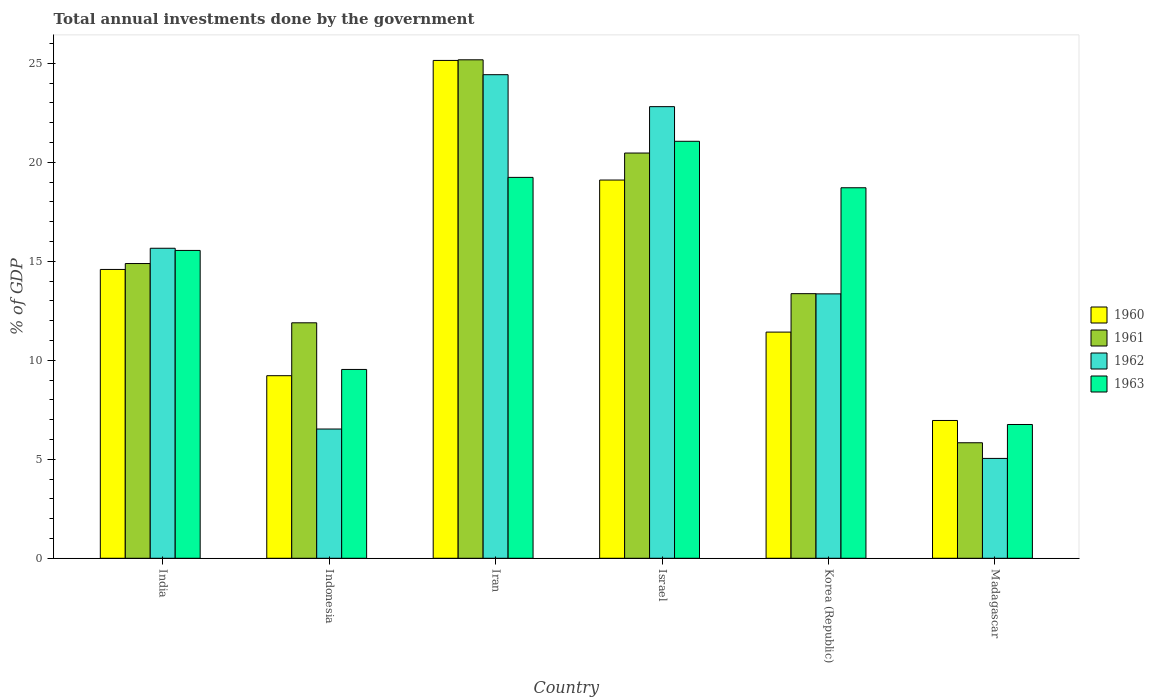How many different coloured bars are there?
Your response must be concise. 4. How many groups of bars are there?
Your answer should be very brief. 6. Are the number of bars per tick equal to the number of legend labels?
Offer a very short reply. Yes. Are the number of bars on each tick of the X-axis equal?
Offer a very short reply. Yes. How many bars are there on the 3rd tick from the left?
Your answer should be compact. 4. What is the label of the 3rd group of bars from the left?
Make the answer very short. Iran. In how many cases, is the number of bars for a given country not equal to the number of legend labels?
Offer a very short reply. 0. What is the total annual investments done by the government in 1962 in Madagascar?
Your response must be concise. 5.04. Across all countries, what is the maximum total annual investments done by the government in 1962?
Offer a terse response. 24.43. Across all countries, what is the minimum total annual investments done by the government in 1963?
Make the answer very short. 6.76. In which country was the total annual investments done by the government in 1962 maximum?
Provide a short and direct response. Iran. In which country was the total annual investments done by the government in 1961 minimum?
Ensure brevity in your answer.  Madagascar. What is the total total annual investments done by the government in 1960 in the graph?
Your answer should be very brief. 86.46. What is the difference between the total annual investments done by the government in 1963 in India and that in Israel?
Give a very brief answer. -5.51. What is the difference between the total annual investments done by the government in 1962 in India and the total annual investments done by the government in 1963 in Israel?
Your response must be concise. -5.4. What is the average total annual investments done by the government in 1962 per country?
Give a very brief answer. 14.64. What is the difference between the total annual investments done by the government of/in 1962 and total annual investments done by the government of/in 1961 in Korea (Republic)?
Your response must be concise. -0.01. What is the ratio of the total annual investments done by the government in 1962 in Iran to that in Madagascar?
Your response must be concise. 4.84. Is the total annual investments done by the government in 1960 in Israel less than that in Madagascar?
Offer a terse response. No. Is the difference between the total annual investments done by the government in 1962 in Indonesia and Iran greater than the difference between the total annual investments done by the government in 1961 in Indonesia and Iran?
Offer a terse response. No. What is the difference between the highest and the second highest total annual investments done by the government in 1962?
Your answer should be compact. 1.61. What is the difference between the highest and the lowest total annual investments done by the government in 1961?
Provide a succinct answer. 19.35. What does the 1st bar from the left in Israel represents?
Your answer should be compact. 1960. How many bars are there?
Offer a terse response. 24. How many countries are there in the graph?
Give a very brief answer. 6. Are the values on the major ticks of Y-axis written in scientific E-notation?
Provide a succinct answer. No. Does the graph contain grids?
Keep it short and to the point. No. How many legend labels are there?
Provide a short and direct response. 4. What is the title of the graph?
Your answer should be very brief. Total annual investments done by the government. Does "1981" appear as one of the legend labels in the graph?
Offer a very short reply. No. What is the label or title of the Y-axis?
Provide a succinct answer. % of GDP. What is the % of GDP in 1960 in India?
Your answer should be very brief. 14.59. What is the % of GDP in 1961 in India?
Provide a succinct answer. 14.89. What is the % of GDP in 1962 in India?
Keep it short and to the point. 15.66. What is the % of GDP in 1963 in India?
Your answer should be compact. 15.55. What is the % of GDP of 1960 in Indonesia?
Your answer should be compact. 9.22. What is the % of GDP in 1961 in Indonesia?
Keep it short and to the point. 11.9. What is the % of GDP in 1962 in Indonesia?
Offer a very short reply. 6.53. What is the % of GDP in 1963 in Indonesia?
Your answer should be compact. 9.54. What is the % of GDP of 1960 in Iran?
Ensure brevity in your answer.  25.15. What is the % of GDP in 1961 in Iran?
Your answer should be very brief. 25.18. What is the % of GDP in 1962 in Iran?
Your response must be concise. 24.43. What is the % of GDP of 1963 in Iran?
Offer a very short reply. 19.24. What is the % of GDP of 1960 in Israel?
Make the answer very short. 19.11. What is the % of GDP of 1961 in Israel?
Give a very brief answer. 20.47. What is the % of GDP of 1962 in Israel?
Provide a succinct answer. 22.82. What is the % of GDP of 1963 in Israel?
Ensure brevity in your answer.  21.06. What is the % of GDP of 1960 in Korea (Republic)?
Make the answer very short. 11.43. What is the % of GDP of 1961 in Korea (Republic)?
Ensure brevity in your answer.  13.37. What is the % of GDP of 1962 in Korea (Republic)?
Make the answer very short. 13.36. What is the % of GDP in 1963 in Korea (Republic)?
Keep it short and to the point. 18.72. What is the % of GDP of 1960 in Madagascar?
Keep it short and to the point. 6.96. What is the % of GDP of 1961 in Madagascar?
Your response must be concise. 5.84. What is the % of GDP of 1962 in Madagascar?
Offer a very short reply. 5.04. What is the % of GDP of 1963 in Madagascar?
Your answer should be very brief. 6.76. Across all countries, what is the maximum % of GDP of 1960?
Offer a very short reply. 25.15. Across all countries, what is the maximum % of GDP of 1961?
Offer a very short reply. 25.18. Across all countries, what is the maximum % of GDP in 1962?
Provide a short and direct response. 24.43. Across all countries, what is the maximum % of GDP of 1963?
Your answer should be very brief. 21.06. Across all countries, what is the minimum % of GDP of 1960?
Provide a short and direct response. 6.96. Across all countries, what is the minimum % of GDP in 1961?
Give a very brief answer. 5.84. Across all countries, what is the minimum % of GDP in 1962?
Provide a succinct answer. 5.04. Across all countries, what is the minimum % of GDP of 1963?
Give a very brief answer. 6.76. What is the total % of GDP of 1960 in the graph?
Your response must be concise. 86.46. What is the total % of GDP of 1961 in the graph?
Offer a terse response. 91.64. What is the total % of GDP in 1962 in the graph?
Give a very brief answer. 87.84. What is the total % of GDP of 1963 in the graph?
Provide a succinct answer. 90.87. What is the difference between the % of GDP of 1960 in India and that in Indonesia?
Provide a short and direct response. 5.37. What is the difference between the % of GDP of 1961 in India and that in Indonesia?
Provide a succinct answer. 2.99. What is the difference between the % of GDP of 1962 in India and that in Indonesia?
Provide a succinct answer. 9.13. What is the difference between the % of GDP in 1963 in India and that in Indonesia?
Your response must be concise. 6.01. What is the difference between the % of GDP of 1960 in India and that in Iran?
Your answer should be very brief. -10.56. What is the difference between the % of GDP in 1961 in India and that in Iran?
Your answer should be very brief. -10.29. What is the difference between the % of GDP in 1962 in India and that in Iran?
Your response must be concise. -8.77. What is the difference between the % of GDP of 1963 in India and that in Iran?
Give a very brief answer. -3.69. What is the difference between the % of GDP of 1960 in India and that in Israel?
Give a very brief answer. -4.52. What is the difference between the % of GDP of 1961 in India and that in Israel?
Keep it short and to the point. -5.58. What is the difference between the % of GDP in 1962 in India and that in Israel?
Keep it short and to the point. -7.15. What is the difference between the % of GDP of 1963 in India and that in Israel?
Offer a terse response. -5.51. What is the difference between the % of GDP in 1960 in India and that in Korea (Republic)?
Keep it short and to the point. 3.17. What is the difference between the % of GDP of 1961 in India and that in Korea (Republic)?
Provide a short and direct response. 1.52. What is the difference between the % of GDP in 1962 in India and that in Korea (Republic)?
Ensure brevity in your answer.  2.3. What is the difference between the % of GDP of 1963 in India and that in Korea (Republic)?
Ensure brevity in your answer.  -3.17. What is the difference between the % of GDP in 1960 in India and that in Madagascar?
Make the answer very short. 7.63. What is the difference between the % of GDP of 1961 in India and that in Madagascar?
Your response must be concise. 9.05. What is the difference between the % of GDP of 1962 in India and that in Madagascar?
Offer a terse response. 10.62. What is the difference between the % of GDP of 1963 in India and that in Madagascar?
Your answer should be compact. 8.79. What is the difference between the % of GDP of 1960 in Indonesia and that in Iran?
Offer a very short reply. -15.93. What is the difference between the % of GDP in 1961 in Indonesia and that in Iran?
Your answer should be very brief. -13.29. What is the difference between the % of GDP of 1962 in Indonesia and that in Iran?
Provide a short and direct response. -17.9. What is the difference between the % of GDP of 1963 in Indonesia and that in Iran?
Keep it short and to the point. -9.7. What is the difference between the % of GDP in 1960 in Indonesia and that in Israel?
Make the answer very short. -9.88. What is the difference between the % of GDP in 1961 in Indonesia and that in Israel?
Your response must be concise. -8.58. What is the difference between the % of GDP in 1962 in Indonesia and that in Israel?
Your answer should be compact. -16.29. What is the difference between the % of GDP in 1963 in Indonesia and that in Israel?
Your answer should be very brief. -11.53. What is the difference between the % of GDP in 1960 in Indonesia and that in Korea (Republic)?
Offer a terse response. -2.2. What is the difference between the % of GDP of 1961 in Indonesia and that in Korea (Republic)?
Provide a short and direct response. -1.47. What is the difference between the % of GDP in 1962 in Indonesia and that in Korea (Republic)?
Offer a terse response. -6.83. What is the difference between the % of GDP in 1963 in Indonesia and that in Korea (Republic)?
Make the answer very short. -9.18. What is the difference between the % of GDP in 1960 in Indonesia and that in Madagascar?
Offer a terse response. 2.26. What is the difference between the % of GDP of 1961 in Indonesia and that in Madagascar?
Your answer should be compact. 6.06. What is the difference between the % of GDP of 1962 in Indonesia and that in Madagascar?
Your answer should be very brief. 1.49. What is the difference between the % of GDP in 1963 in Indonesia and that in Madagascar?
Ensure brevity in your answer.  2.78. What is the difference between the % of GDP of 1960 in Iran and that in Israel?
Offer a terse response. 6.04. What is the difference between the % of GDP of 1961 in Iran and that in Israel?
Ensure brevity in your answer.  4.71. What is the difference between the % of GDP of 1962 in Iran and that in Israel?
Provide a succinct answer. 1.61. What is the difference between the % of GDP in 1963 in Iran and that in Israel?
Offer a very short reply. -1.82. What is the difference between the % of GDP in 1960 in Iran and that in Korea (Republic)?
Your answer should be very brief. 13.72. What is the difference between the % of GDP in 1961 in Iran and that in Korea (Republic)?
Give a very brief answer. 11.81. What is the difference between the % of GDP in 1962 in Iran and that in Korea (Republic)?
Make the answer very short. 11.07. What is the difference between the % of GDP in 1963 in Iran and that in Korea (Republic)?
Offer a very short reply. 0.52. What is the difference between the % of GDP of 1960 in Iran and that in Madagascar?
Give a very brief answer. 18.19. What is the difference between the % of GDP of 1961 in Iran and that in Madagascar?
Offer a very short reply. 19.35. What is the difference between the % of GDP in 1962 in Iran and that in Madagascar?
Ensure brevity in your answer.  19.38. What is the difference between the % of GDP in 1963 in Iran and that in Madagascar?
Offer a very short reply. 12.48. What is the difference between the % of GDP in 1960 in Israel and that in Korea (Republic)?
Keep it short and to the point. 7.68. What is the difference between the % of GDP of 1961 in Israel and that in Korea (Republic)?
Your response must be concise. 7.1. What is the difference between the % of GDP of 1962 in Israel and that in Korea (Republic)?
Give a very brief answer. 9.46. What is the difference between the % of GDP of 1963 in Israel and that in Korea (Republic)?
Ensure brevity in your answer.  2.35. What is the difference between the % of GDP in 1960 in Israel and that in Madagascar?
Make the answer very short. 12.15. What is the difference between the % of GDP in 1961 in Israel and that in Madagascar?
Give a very brief answer. 14.64. What is the difference between the % of GDP in 1962 in Israel and that in Madagascar?
Your answer should be very brief. 17.77. What is the difference between the % of GDP of 1963 in Israel and that in Madagascar?
Make the answer very short. 14.31. What is the difference between the % of GDP of 1960 in Korea (Republic) and that in Madagascar?
Keep it short and to the point. 4.46. What is the difference between the % of GDP of 1961 in Korea (Republic) and that in Madagascar?
Keep it short and to the point. 7.53. What is the difference between the % of GDP of 1962 in Korea (Republic) and that in Madagascar?
Your answer should be very brief. 8.31. What is the difference between the % of GDP in 1963 in Korea (Republic) and that in Madagascar?
Make the answer very short. 11.96. What is the difference between the % of GDP in 1960 in India and the % of GDP in 1961 in Indonesia?
Provide a short and direct response. 2.7. What is the difference between the % of GDP in 1960 in India and the % of GDP in 1962 in Indonesia?
Provide a succinct answer. 8.06. What is the difference between the % of GDP of 1960 in India and the % of GDP of 1963 in Indonesia?
Make the answer very short. 5.05. What is the difference between the % of GDP in 1961 in India and the % of GDP in 1962 in Indonesia?
Provide a short and direct response. 8.36. What is the difference between the % of GDP in 1961 in India and the % of GDP in 1963 in Indonesia?
Offer a very short reply. 5.35. What is the difference between the % of GDP in 1962 in India and the % of GDP in 1963 in Indonesia?
Offer a very short reply. 6.12. What is the difference between the % of GDP in 1960 in India and the % of GDP in 1961 in Iran?
Keep it short and to the point. -10.59. What is the difference between the % of GDP of 1960 in India and the % of GDP of 1962 in Iran?
Offer a very short reply. -9.84. What is the difference between the % of GDP in 1960 in India and the % of GDP in 1963 in Iran?
Give a very brief answer. -4.65. What is the difference between the % of GDP in 1961 in India and the % of GDP in 1962 in Iran?
Your response must be concise. -9.54. What is the difference between the % of GDP of 1961 in India and the % of GDP of 1963 in Iran?
Your response must be concise. -4.35. What is the difference between the % of GDP of 1962 in India and the % of GDP of 1963 in Iran?
Offer a very short reply. -3.58. What is the difference between the % of GDP in 1960 in India and the % of GDP in 1961 in Israel?
Ensure brevity in your answer.  -5.88. What is the difference between the % of GDP in 1960 in India and the % of GDP in 1962 in Israel?
Your answer should be very brief. -8.22. What is the difference between the % of GDP in 1960 in India and the % of GDP in 1963 in Israel?
Ensure brevity in your answer.  -6.47. What is the difference between the % of GDP in 1961 in India and the % of GDP in 1962 in Israel?
Your answer should be very brief. -7.93. What is the difference between the % of GDP of 1961 in India and the % of GDP of 1963 in Israel?
Provide a short and direct response. -6.18. What is the difference between the % of GDP in 1962 in India and the % of GDP in 1963 in Israel?
Give a very brief answer. -5.4. What is the difference between the % of GDP of 1960 in India and the % of GDP of 1961 in Korea (Republic)?
Your answer should be very brief. 1.22. What is the difference between the % of GDP in 1960 in India and the % of GDP in 1962 in Korea (Republic)?
Your answer should be compact. 1.23. What is the difference between the % of GDP in 1960 in India and the % of GDP in 1963 in Korea (Republic)?
Your response must be concise. -4.13. What is the difference between the % of GDP in 1961 in India and the % of GDP in 1962 in Korea (Republic)?
Your answer should be very brief. 1.53. What is the difference between the % of GDP in 1961 in India and the % of GDP in 1963 in Korea (Republic)?
Your answer should be very brief. -3.83. What is the difference between the % of GDP in 1962 in India and the % of GDP in 1963 in Korea (Republic)?
Provide a short and direct response. -3.06. What is the difference between the % of GDP in 1960 in India and the % of GDP in 1961 in Madagascar?
Provide a succinct answer. 8.76. What is the difference between the % of GDP of 1960 in India and the % of GDP of 1962 in Madagascar?
Provide a succinct answer. 9.55. What is the difference between the % of GDP in 1960 in India and the % of GDP in 1963 in Madagascar?
Your answer should be compact. 7.83. What is the difference between the % of GDP of 1961 in India and the % of GDP of 1962 in Madagascar?
Provide a succinct answer. 9.84. What is the difference between the % of GDP in 1961 in India and the % of GDP in 1963 in Madagascar?
Your response must be concise. 8.13. What is the difference between the % of GDP of 1962 in India and the % of GDP of 1963 in Madagascar?
Your answer should be compact. 8.9. What is the difference between the % of GDP in 1960 in Indonesia and the % of GDP in 1961 in Iran?
Offer a very short reply. -15.96. What is the difference between the % of GDP of 1960 in Indonesia and the % of GDP of 1962 in Iran?
Offer a very short reply. -15.21. What is the difference between the % of GDP in 1960 in Indonesia and the % of GDP in 1963 in Iran?
Your response must be concise. -10.02. What is the difference between the % of GDP in 1961 in Indonesia and the % of GDP in 1962 in Iran?
Your answer should be compact. -12.53. What is the difference between the % of GDP in 1961 in Indonesia and the % of GDP in 1963 in Iran?
Make the answer very short. -7.35. What is the difference between the % of GDP in 1962 in Indonesia and the % of GDP in 1963 in Iran?
Make the answer very short. -12.71. What is the difference between the % of GDP of 1960 in Indonesia and the % of GDP of 1961 in Israel?
Give a very brief answer. -11.25. What is the difference between the % of GDP in 1960 in Indonesia and the % of GDP in 1962 in Israel?
Your response must be concise. -13.59. What is the difference between the % of GDP of 1960 in Indonesia and the % of GDP of 1963 in Israel?
Provide a succinct answer. -11.84. What is the difference between the % of GDP of 1961 in Indonesia and the % of GDP of 1962 in Israel?
Your answer should be very brief. -10.92. What is the difference between the % of GDP in 1961 in Indonesia and the % of GDP in 1963 in Israel?
Provide a short and direct response. -9.17. What is the difference between the % of GDP of 1962 in Indonesia and the % of GDP of 1963 in Israel?
Provide a succinct answer. -14.54. What is the difference between the % of GDP in 1960 in Indonesia and the % of GDP in 1961 in Korea (Republic)?
Offer a very short reply. -4.14. What is the difference between the % of GDP of 1960 in Indonesia and the % of GDP of 1962 in Korea (Republic)?
Your answer should be very brief. -4.13. What is the difference between the % of GDP in 1960 in Indonesia and the % of GDP in 1963 in Korea (Republic)?
Your response must be concise. -9.49. What is the difference between the % of GDP in 1961 in Indonesia and the % of GDP in 1962 in Korea (Republic)?
Offer a terse response. -1.46. What is the difference between the % of GDP of 1961 in Indonesia and the % of GDP of 1963 in Korea (Republic)?
Ensure brevity in your answer.  -6.82. What is the difference between the % of GDP in 1962 in Indonesia and the % of GDP in 1963 in Korea (Republic)?
Offer a terse response. -12.19. What is the difference between the % of GDP in 1960 in Indonesia and the % of GDP in 1961 in Madagascar?
Offer a very short reply. 3.39. What is the difference between the % of GDP in 1960 in Indonesia and the % of GDP in 1962 in Madagascar?
Keep it short and to the point. 4.18. What is the difference between the % of GDP of 1960 in Indonesia and the % of GDP of 1963 in Madagascar?
Your response must be concise. 2.47. What is the difference between the % of GDP of 1961 in Indonesia and the % of GDP of 1962 in Madagascar?
Ensure brevity in your answer.  6.85. What is the difference between the % of GDP in 1961 in Indonesia and the % of GDP in 1963 in Madagascar?
Offer a terse response. 5.14. What is the difference between the % of GDP of 1962 in Indonesia and the % of GDP of 1963 in Madagascar?
Provide a succinct answer. -0.23. What is the difference between the % of GDP of 1960 in Iran and the % of GDP of 1961 in Israel?
Your response must be concise. 4.68. What is the difference between the % of GDP in 1960 in Iran and the % of GDP in 1962 in Israel?
Offer a terse response. 2.33. What is the difference between the % of GDP of 1960 in Iran and the % of GDP of 1963 in Israel?
Offer a terse response. 4.08. What is the difference between the % of GDP of 1961 in Iran and the % of GDP of 1962 in Israel?
Ensure brevity in your answer.  2.37. What is the difference between the % of GDP of 1961 in Iran and the % of GDP of 1963 in Israel?
Make the answer very short. 4.12. What is the difference between the % of GDP in 1962 in Iran and the % of GDP in 1963 in Israel?
Provide a succinct answer. 3.36. What is the difference between the % of GDP in 1960 in Iran and the % of GDP in 1961 in Korea (Republic)?
Make the answer very short. 11.78. What is the difference between the % of GDP in 1960 in Iran and the % of GDP in 1962 in Korea (Republic)?
Provide a short and direct response. 11.79. What is the difference between the % of GDP of 1960 in Iran and the % of GDP of 1963 in Korea (Republic)?
Your response must be concise. 6.43. What is the difference between the % of GDP in 1961 in Iran and the % of GDP in 1962 in Korea (Republic)?
Keep it short and to the point. 11.82. What is the difference between the % of GDP in 1961 in Iran and the % of GDP in 1963 in Korea (Republic)?
Ensure brevity in your answer.  6.46. What is the difference between the % of GDP of 1962 in Iran and the % of GDP of 1963 in Korea (Republic)?
Ensure brevity in your answer.  5.71. What is the difference between the % of GDP of 1960 in Iran and the % of GDP of 1961 in Madagascar?
Provide a short and direct response. 19.31. What is the difference between the % of GDP in 1960 in Iran and the % of GDP in 1962 in Madagascar?
Offer a very short reply. 20.11. What is the difference between the % of GDP of 1960 in Iran and the % of GDP of 1963 in Madagascar?
Ensure brevity in your answer.  18.39. What is the difference between the % of GDP of 1961 in Iran and the % of GDP of 1962 in Madagascar?
Make the answer very short. 20.14. What is the difference between the % of GDP of 1961 in Iran and the % of GDP of 1963 in Madagascar?
Your answer should be very brief. 18.42. What is the difference between the % of GDP in 1962 in Iran and the % of GDP in 1963 in Madagascar?
Provide a succinct answer. 17.67. What is the difference between the % of GDP in 1960 in Israel and the % of GDP in 1961 in Korea (Republic)?
Ensure brevity in your answer.  5.74. What is the difference between the % of GDP of 1960 in Israel and the % of GDP of 1962 in Korea (Republic)?
Provide a succinct answer. 5.75. What is the difference between the % of GDP in 1960 in Israel and the % of GDP in 1963 in Korea (Republic)?
Provide a short and direct response. 0.39. What is the difference between the % of GDP of 1961 in Israel and the % of GDP of 1962 in Korea (Republic)?
Your answer should be compact. 7.11. What is the difference between the % of GDP of 1961 in Israel and the % of GDP of 1963 in Korea (Republic)?
Your answer should be compact. 1.75. What is the difference between the % of GDP in 1962 in Israel and the % of GDP in 1963 in Korea (Republic)?
Provide a succinct answer. 4.1. What is the difference between the % of GDP of 1960 in Israel and the % of GDP of 1961 in Madagascar?
Give a very brief answer. 13.27. What is the difference between the % of GDP of 1960 in Israel and the % of GDP of 1962 in Madagascar?
Give a very brief answer. 14.06. What is the difference between the % of GDP in 1960 in Israel and the % of GDP in 1963 in Madagascar?
Offer a terse response. 12.35. What is the difference between the % of GDP of 1961 in Israel and the % of GDP of 1962 in Madagascar?
Your answer should be compact. 15.43. What is the difference between the % of GDP of 1961 in Israel and the % of GDP of 1963 in Madagascar?
Keep it short and to the point. 13.71. What is the difference between the % of GDP in 1962 in Israel and the % of GDP in 1963 in Madagascar?
Ensure brevity in your answer.  16.06. What is the difference between the % of GDP in 1960 in Korea (Republic) and the % of GDP in 1961 in Madagascar?
Your answer should be compact. 5.59. What is the difference between the % of GDP in 1960 in Korea (Republic) and the % of GDP in 1962 in Madagascar?
Provide a short and direct response. 6.38. What is the difference between the % of GDP of 1960 in Korea (Republic) and the % of GDP of 1963 in Madagascar?
Provide a succinct answer. 4.67. What is the difference between the % of GDP in 1961 in Korea (Republic) and the % of GDP in 1962 in Madagascar?
Give a very brief answer. 8.32. What is the difference between the % of GDP of 1961 in Korea (Republic) and the % of GDP of 1963 in Madagascar?
Offer a terse response. 6.61. What is the difference between the % of GDP of 1962 in Korea (Republic) and the % of GDP of 1963 in Madagascar?
Offer a very short reply. 6.6. What is the average % of GDP in 1960 per country?
Your answer should be very brief. 14.41. What is the average % of GDP of 1961 per country?
Give a very brief answer. 15.27. What is the average % of GDP of 1962 per country?
Provide a succinct answer. 14.64. What is the average % of GDP in 1963 per country?
Your response must be concise. 15.15. What is the difference between the % of GDP in 1960 and % of GDP in 1961 in India?
Offer a very short reply. -0.3. What is the difference between the % of GDP of 1960 and % of GDP of 1962 in India?
Offer a very short reply. -1.07. What is the difference between the % of GDP of 1960 and % of GDP of 1963 in India?
Give a very brief answer. -0.96. What is the difference between the % of GDP in 1961 and % of GDP in 1962 in India?
Provide a short and direct response. -0.77. What is the difference between the % of GDP in 1961 and % of GDP in 1963 in India?
Give a very brief answer. -0.66. What is the difference between the % of GDP in 1962 and % of GDP in 1963 in India?
Your answer should be compact. 0.11. What is the difference between the % of GDP of 1960 and % of GDP of 1961 in Indonesia?
Your answer should be very brief. -2.67. What is the difference between the % of GDP of 1960 and % of GDP of 1962 in Indonesia?
Your answer should be compact. 2.69. What is the difference between the % of GDP of 1960 and % of GDP of 1963 in Indonesia?
Offer a terse response. -0.32. What is the difference between the % of GDP of 1961 and % of GDP of 1962 in Indonesia?
Your response must be concise. 5.37. What is the difference between the % of GDP in 1961 and % of GDP in 1963 in Indonesia?
Offer a very short reply. 2.36. What is the difference between the % of GDP in 1962 and % of GDP in 1963 in Indonesia?
Offer a very short reply. -3.01. What is the difference between the % of GDP of 1960 and % of GDP of 1961 in Iran?
Offer a very short reply. -0.03. What is the difference between the % of GDP of 1960 and % of GDP of 1962 in Iran?
Offer a very short reply. 0.72. What is the difference between the % of GDP in 1960 and % of GDP in 1963 in Iran?
Make the answer very short. 5.91. What is the difference between the % of GDP in 1961 and % of GDP in 1962 in Iran?
Provide a succinct answer. 0.75. What is the difference between the % of GDP of 1961 and % of GDP of 1963 in Iran?
Provide a short and direct response. 5.94. What is the difference between the % of GDP of 1962 and % of GDP of 1963 in Iran?
Provide a succinct answer. 5.19. What is the difference between the % of GDP in 1960 and % of GDP in 1961 in Israel?
Your answer should be compact. -1.36. What is the difference between the % of GDP in 1960 and % of GDP in 1962 in Israel?
Offer a terse response. -3.71. What is the difference between the % of GDP in 1960 and % of GDP in 1963 in Israel?
Keep it short and to the point. -1.96. What is the difference between the % of GDP in 1961 and % of GDP in 1962 in Israel?
Make the answer very short. -2.34. What is the difference between the % of GDP in 1961 and % of GDP in 1963 in Israel?
Provide a succinct answer. -0.59. What is the difference between the % of GDP in 1962 and % of GDP in 1963 in Israel?
Make the answer very short. 1.75. What is the difference between the % of GDP in 1960 and % of GDP in 1961 in Korea (Republic)?
Make the answer very short. -1.94. What is the difference between the % of GDP in 1960 and % of GDP in 1962 in Korea (Republic)?
Your response must be concise. -1.93. What is the difference between the % of GDP in 1960 and % of GDP in 1963 in Korea (Republic)?
Offer a very short reply. -7.29. What is the difference between the % of GDP of 1961 and % of GDP of 1962 in Korea (Republic)?
Make the answer very short. 0.01. What is the difference between the % of GDP of 1961 and % of GDP of 1963 in Korea (Republic)?
Your answer should be very brief. -5.35. What is the difference between the % of GDP of 1962 and % of GDP of 1963 in Korea (Republic)?
Ensure brevity in your answer.  -5.36. What is the difference between the % of GDP in 1960 and % of GDP in 1961 in Madagascar?
Your answer should be compact. 1.13. What is the difference between the % of GDP of 1960 and % of GDP of 1962 in Madagascar?
Provide a succinct answer. 1.92. What is the difference between the % of GDP of 1960 and % of GDP of 1963 in Madagascar?
Provide a succinct answer. 0.2. What is the difference between the % of GDP of 1961 and % of GDP of 1962 in Madagascar?
Make the answer very short. 0.79. What is the difference between the % of GDP of 1961 and % of GDP of 1963 in Madagascar?
Offer a very short reply. -0.92. What is the difference between the % of GDP in 1962 and % of GDP in 1963 in Madagascar?
Make the answer very short. -1.71. What is the ratio of the % of GDP in 1960 in India to that in Indonesia?
Offer a very short reply. 1.58. What is the ratio of the % of GDP in 1961 in India to that in Indonesia?
Offer a terse response. 1.25. What is the ratio of the % of GDP in 1962 in India to that in Indonesia?
Provide a short and direct response. 2.4. What is the ratio of the % of GDP of 1963 in India to that in Indonesia?
Your answer should be very brief. 1.63. What is the ratio of the % of GDP in 1960 in India to that in Iran?
Give a very brief answer. 0.58. What is the ratio of the % of GDP of 1961 in India to that in Iran?
Your answer should be very brief. 0.59. What is the ratio of the % of GDP in 1962 in India to that in Iran?
Your answer should be compact. 0.64. What is the ratio of the % of GDP of 1963 in India to that in Iran?
Ensure brevity in your answer.  0.81. What is the ratio of the % of GDP of 1960 in India to that in Israel?
Give a very brief answer. 0.76. What is the ratio of the % of GDP in 1961 in India to that in Israel?
Make the answer very short. 0.73. What is the ratio of the % of GDP in 1962 in India to that in Israel?
Offer a very short reply. 0.69. What is the ratio of the % of GDP in 1963 in India to that in Israel?
Provide a succinct answer. 0.74. What is the ratio of the % of GDP in 1960 in India to that in Korea (Republic)?
Your response must be concise. 1.28. What is the ratio of the % of GDP in 1961 in India to that in Korea (Republic)?
Provide a succinct answer. 1.11. What is the ratio of the % of GDP of 1962 in India to that in Korea (Republic)?
Offer a very short reply. 1.17. What is the ratio of the % of GDP of 1963 in India to that in Korea (Republic)?
Offer a very short reply. 0.83. What is the ratio of the % of GDP in 1960 in India to that in Madagascar?
Provide a short and direct response. 2.1. What is the ratio of the % of GDP in 1961 in India to that in Madagascar?
Make the answer very short. 2.55. What is the ratio of the % of GDP in 1962 in India to that in Madagascar?
Ensure brevity in your answer.  3.1. What is the ratio of the % of GDP in 1963 in India to that in Madagascar?
Ensure brevity in your answer.  2.3. What is the ratio of the % of GDP of 1960 in Indonesia to that in Iran?
Provide a short and direct response. 0.37. What is the ratio of the % of GDP in 1961 in Indonesia to that in Iran?
Your response must be concise. 0.47. What is the ratio of the % of GDP of 1962 in Indonesia to that in Iran?
Provide a succinct answer. 0.27. What is the ratio of the % of GDP in 1963 in Indonesia to that in Iran?
Your answer should be very brief. 0.5. What is the ratio of the % of GDP in 1960 in Indonesia to that in Israel?
Offer a very short reply. 0.48. What is the ratio of the % of GDP in 1961 in Indonesia to that in Israel?
Your answer should be very brief. 0.58. What is the ratio of the % of GDP of 1962 in Indonesia to that in Israel?
Provide a succinct answer. 0.29. What is the ratio of the % of GDP in 1963 in Indonesia to that in Israel?
Make the answer very short. 0.45. What is the ratio of the % of GDP of 1960 in Indonesia to that in Korea (Republic)?
Offer a terse response. 0.81. What is the ratio of the % of GDP in 1961 in Indonesia to that in Korea (Republic)?
Make the answer very short. 0.89. What is the ratio of the % of GDP in 1962 in Indonesia to that in Korea (Republic)?
Offer a very short reply. 0.49. What is the ratio of the % of GDP in 1963 in Indonesia to that in Korea (Republic)?
Provide a short and direct response. 0.51. What is the ratio of the % of GDP in 1960 in Indonesia to that in Madagascar?
Provide a short and direct response. 1.32. What is the ratio of the % of GDP in 1961 in Indonesia to that in Madagascar?
Your response must be concise. 2.04. What is the ratio of the % of GDP of 1962 in Indonesia to that in Madagascar?
Keep it short and to the point. 1.29. What is the ratio of the % of GDP in 1963 in Indonesia to that in Madagascar?
Offer a terse response. 1.41. What is the ratio of the % of GDP of 1960 in Iran to that in Israel?
Make the answer very short. 1.32. What is the ratio of the % of GDP in 1961 in Iran to that in Israel?
Make the answer very short. 1.23. What is the ratio of the % of GDP in 1962 in Iran to that in Israel?
Keep it short and to the point. 1.07. What is the ratio of the % of GDP in 1963 in Iran to that in Israel?
Offer a very short reply. 0.91. What is the ratio of the % of GDP of 1960 in Iran to that in Korea (Republic)?
Provide a succinct answer. 2.2. What is the ratio of the % of GDP of 1961 in Iran to that in Korea (Republic)?
Provide a succinct answer. 1.88. What is the ratio of the % of GDP of 1962 in Iran to that in Korea (Republic)?
Provide a short and direct response. 1.83. What is the ratio of the % of GDP in 1963 in Iran to that in Korea (Republic)?
Your response must be concise. 1.03. What is the ratio of the % of GDP in 1960 in Iran to that in Madagascar?
Offer a terse response. 3.61. What is the ratio of the % of GDP of 1961 in Iran to that in Madagascar?
Your answer should be compact. 4.32. What is the ratio of the % of GDP in 1962 in Iran to that in Madagascar?
Keep it short and to the point. 4.84. What is the ratio of the % of GDP in 1963 in Iran to that in Madagascar?
Provide a succinct answer. 2.85. What is the ratio of the % of GDP of 1960 in Israel to that in Korea (Republic)?
Offer a terse response. 1.67. What is the ratio of the % of GDP of 1961 in Israel to that in Korea (Republic)?
Your response must be concise. 1.53. What is the ratio of the % of GDP in 1962 in Israel to that in Korea (Republic)?
Ensure brevity in your answer.  1.71. What is the ratio of the % of GDP of 1963 in Israel to that in Korea (Republic)?
Make the answer very short. 1.13. What is the ratio of the % of GDP of 1960 in Israel to that in Madagascar?
Your answer should be very brief. 2.74. What is the ratio of the % of GDP of 1961 in Israel to that in Madagascar?
Your response must be concise. 3.51. What is the ratio of the % of GDP in 1962 in Israel to that in Madagascar?
Your answer should be very brief. 4.52. What is the ratio of the % of GDP in 1963 in Israel to that in Madagascar?
Your answer should be compact. 3.12. What is the ratio of the % of GDP of 1960 in Korea (Republic) to that in Madagascar?
Your response must be concise. 1.64. What is the ratio of the % of GDP in 1961 in Korea (Republic) to that in Madagascar?
Your answer should be very brief. 2.29. What is the ratio of the % of GDP of 1962 in Korea (Republic) to that in Madagascar?
Ensure brevity in your answer.  2.65. What is the ratio of the % of GDP in 1963 in Korea (Republic) to that in Madagascar?
Your answer should be compact. 2.77. What is the difference between the highest and the second highest % of GDP of 1960?
Your answer should be very brief. 6.04. What is the difference between the highest and the second highest % of GDP in 1961?
Offer a terse response. 4.71. What is the difference between the highest and the second highest % of GDP of 1962?
Ensure brevity in your answer.  1.61. What is the difference between the highest and the second highest % of GDP of 1963?
Ensure brevity in your answer.  1.82. What is the difference between the highest and the lowest % of GDP of 1960?
Offer a very short reply. 18.19. What is the difference between the highest and the lowest % of GDP of 1961?
Your answer should be compact. 19.35. What is the difference between the highest and the lowest % of GDP of 1962?
Your answer should be compact. 19.38. What is the difference between the highest and the lowest % of GDP in 1963?
Keep it short and to the point. 14.31. 